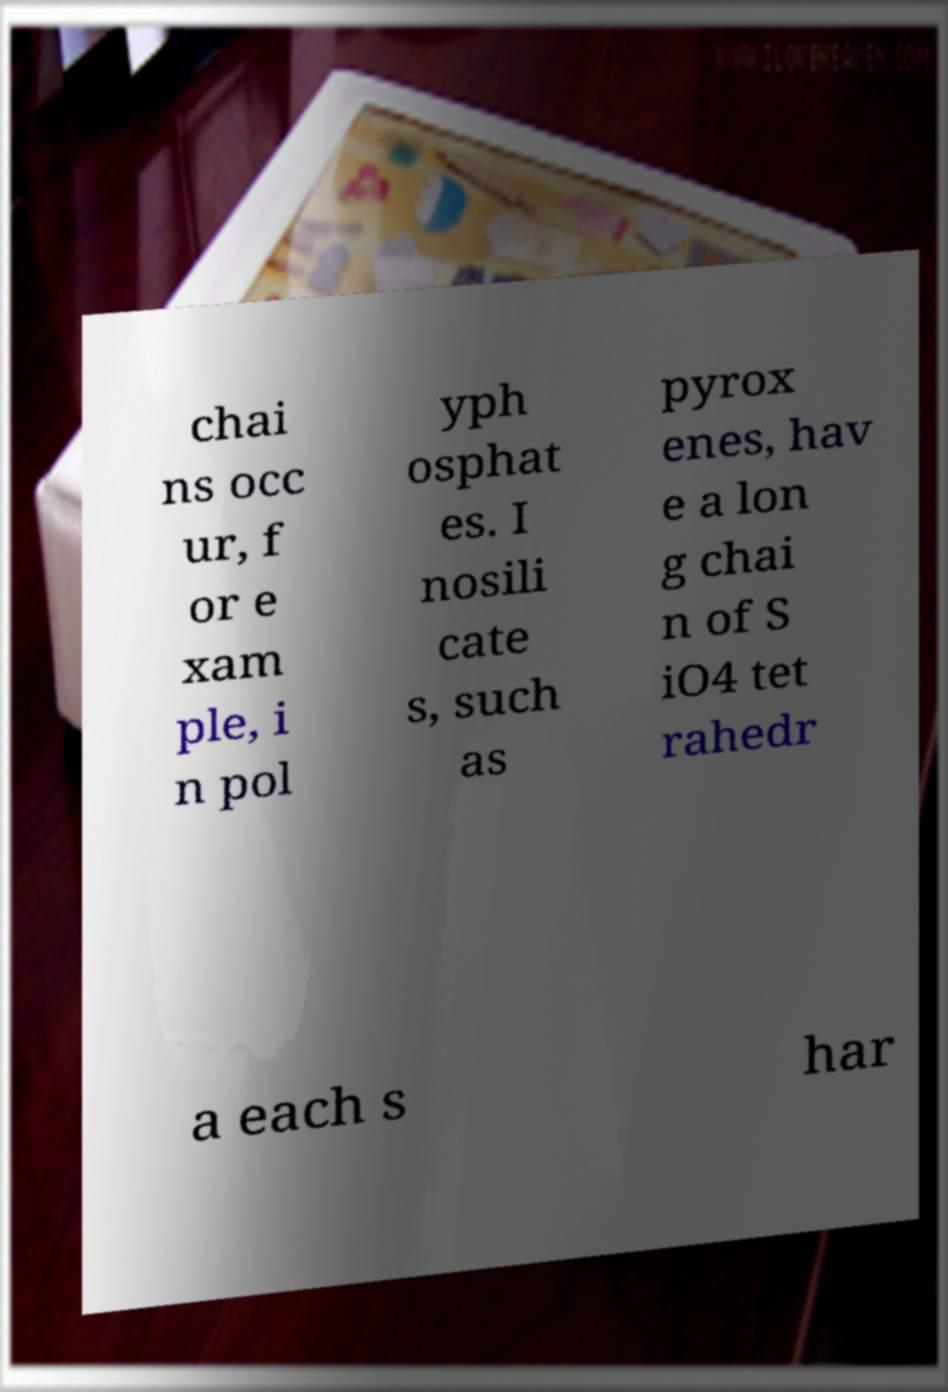Could you extract and type out the text from this image? chai ns occ ur, f or e xam ple, i n pol yph osphat es. I nosili cate s, such as pyrox enes, hav e a lon g chai n of S iO4 tet rahedr a each s har 